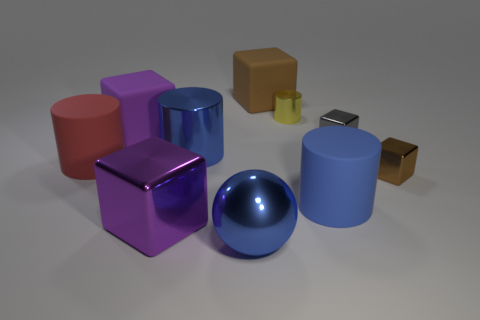There is a small yellow object that is the same shape as the blue matte thing; what is it made of?
Make the answer very short. Metal. What number of matte objects have the same size as the blue metallic cylinder?
Your response must be concise. 4. There is a large ball that is made of the same material as the tiny gray cube; what color is it?
Offer a terse response. Blue. Are there fewer purple blocks than metal blocks?
Offer a very short reply. Yes. How many brown objects are small metallic cylinders or big balls?
Your answer should be compact. 0. What number of purple blocks are both in front of the brown shiny object and left of the big shiny cube?
Ensure brevity in your answer.  0. Is the material of the big blue sphere the same as the red object?
Give a very brief answer. No. There is a yellow shiny thing that is the same size as the brown shiny thing; what shape is it?
Provide a succinct answer. Cylinder. Is the number of matte objects greater than the number of large blue shiny cylinders?
Ensure brevity in your answer.  Yes. What is the blue thing that is behind the blue shiny sphere and left of the small yellow metal cylinder made of?
Keep it short and to the point. Metal. 